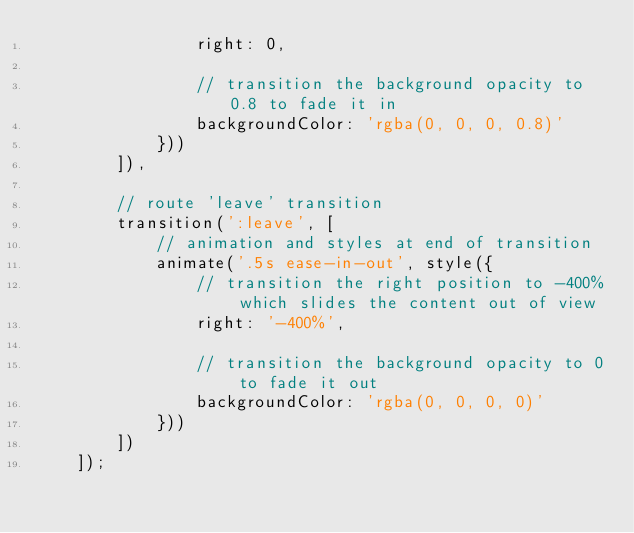Convert code to text. <code><loc_0><loc_0><loc_500><loc_500><_TypeScript_>                right: 0,

                // transition the background opacity to 0.8 to fade it in
                backgroundColor: 'rgba(0, 0, 0, 0.8)'
            }))
        ]),

        // route 'leave' transition
        transition(':leave', [
            // animation and styles at end of transition
            animate('.5s ease-in-out', style({
                // transition the right position to -400% which slides the content out of view
                right: '-400%',

                // transition the background opacity to 0 to fade it out
                backgroundColor: 'rgba(0, 0, 0, 0)'
            }))
        ])
    ]);
    
</code> 